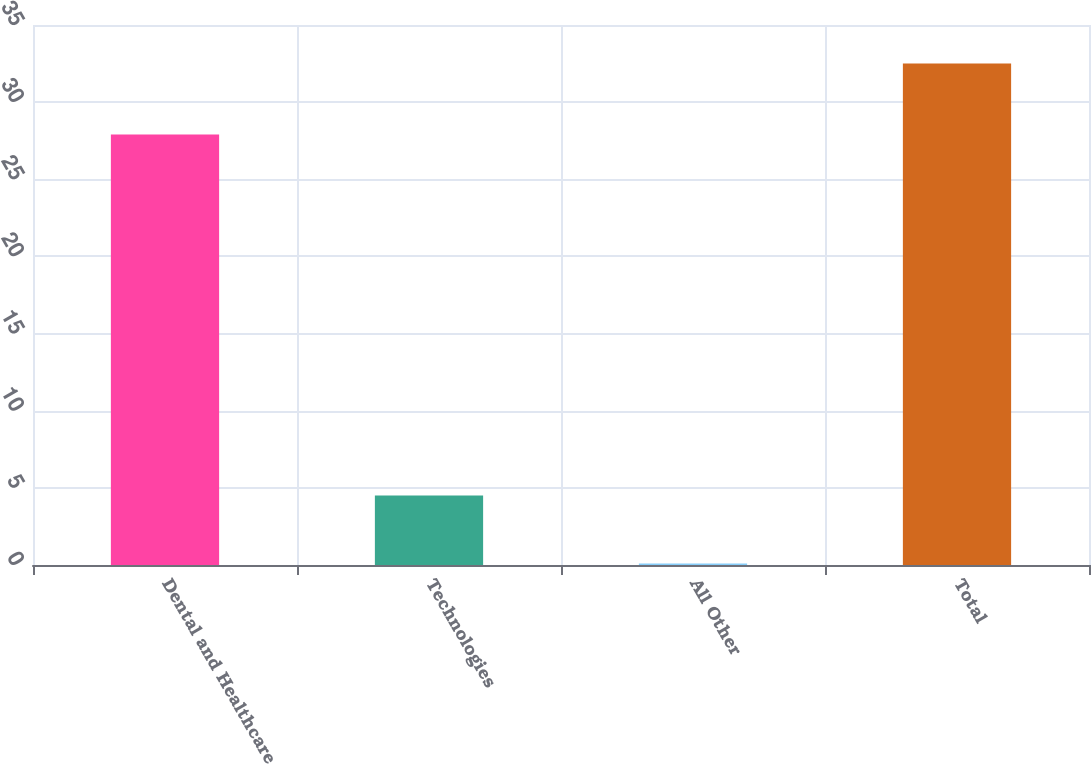Convert chart to OTSL. <chart><loc_0><loc_0><loc_500><loc_500><bar_chart><fcel>Dental and Healthcare<fcel>Technologies<fcel>All Other<fcel>Total<nl><fcel>27.9<fcel>4.5<fcel>0.1<fcel>32.5<nl></chart> 